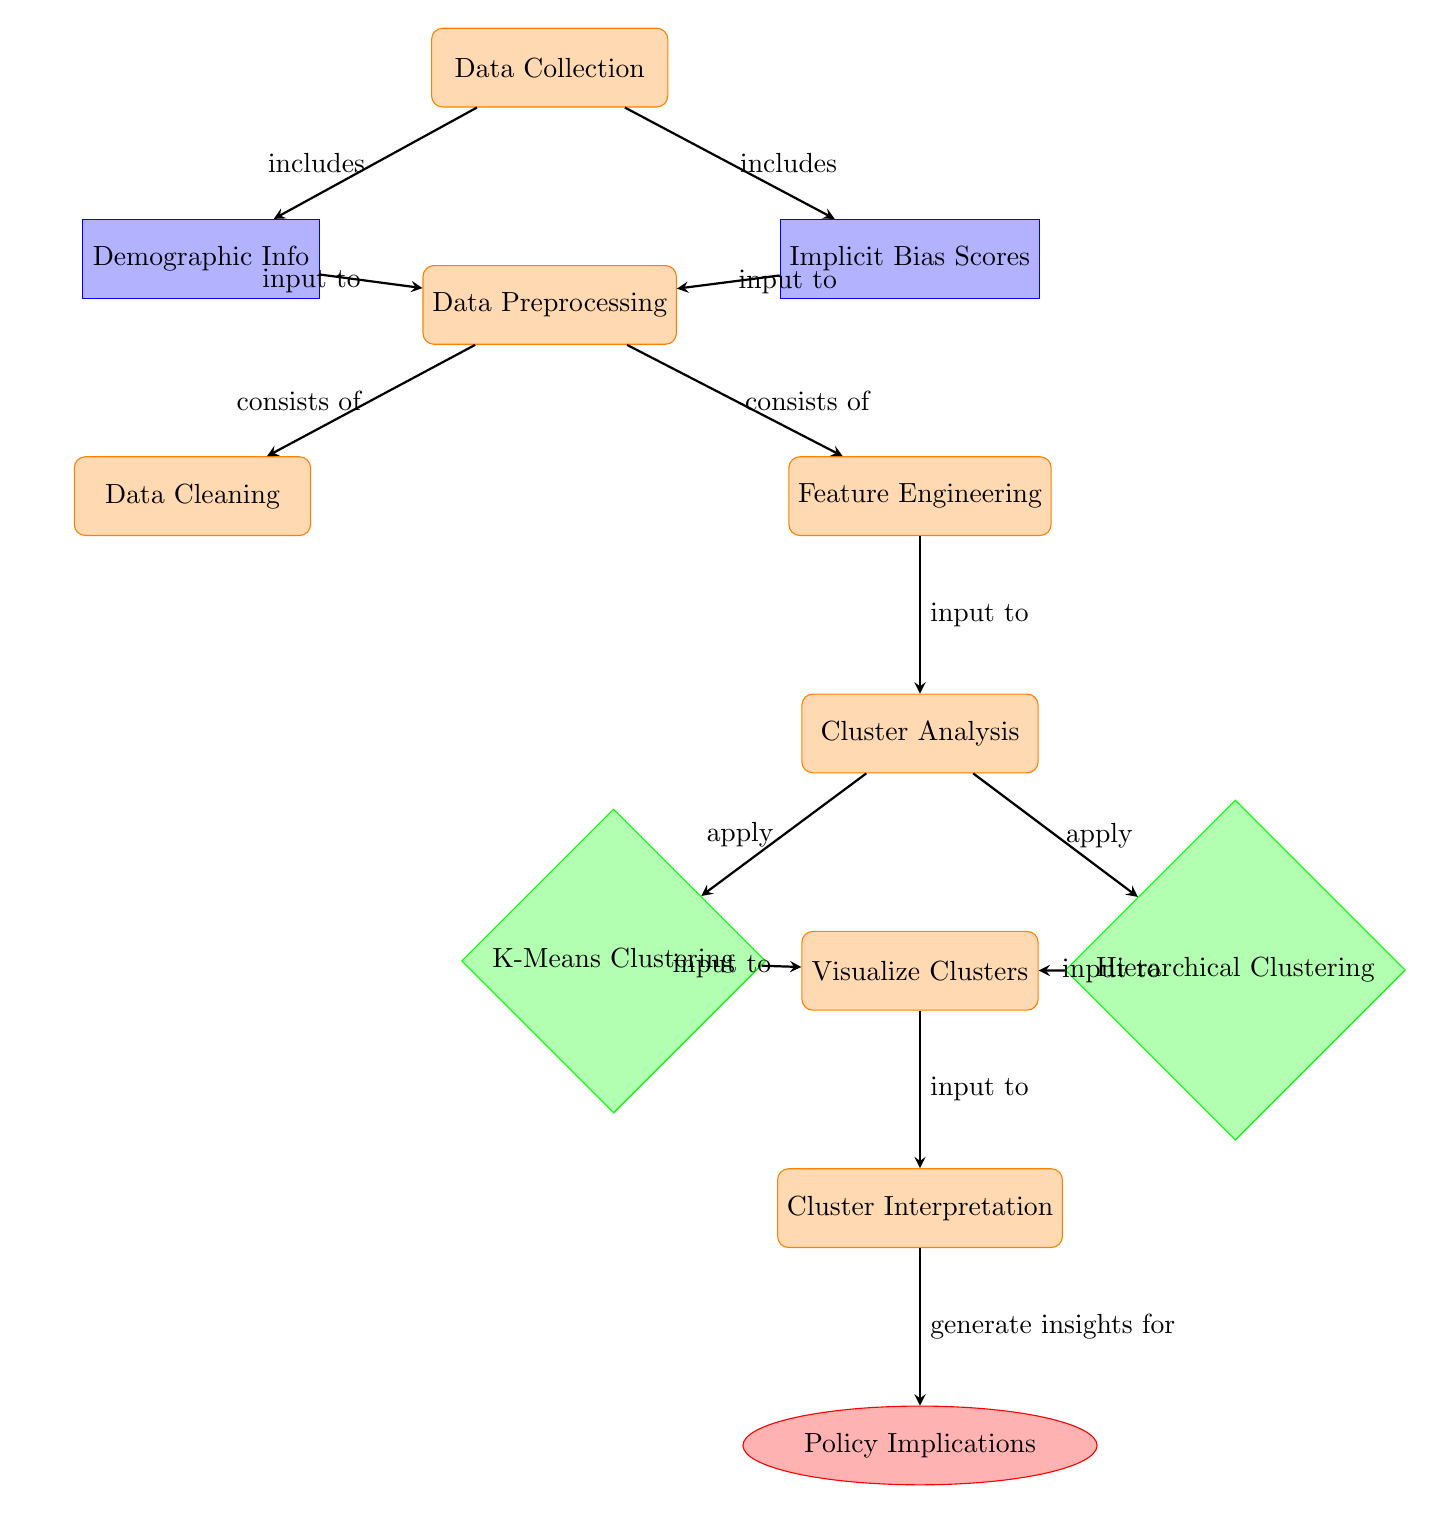What is the first step in the diagram? The first step in the diagram is "Data Collection," which is represented at the top of the flow. It indicates the initial action taken in the process before moving to the next steps.
Answer: Data Collection How many algorithms are used for clustering in the diagram? The diagram shows two algorithms used for clustering: "K-Means Clustering" and "Hierarchical Clustering." They are specifically indicated in the diagram under the cluster analysis.
Answer: 2 Which process comes directly after "Data Cleaning"? After "Data Cleaning," the next process in the diagram is "Feature Engineering." This follows the connections between nodes depicted in the process flow.
Answer: Feature Engineering What is the outcome of this diagram? The final output of the diagram is "Policy Implications," positioned at the bottom as the ultimate goal of the entire analysis workflow.
Answer: Policy Implications What connects "Implicit Bias Scores" to "Data Preprocessing"? The connection is established by an arrow labeled "input to," indicating that "Implicit Bias Scores" serve as input in the "Data Preprocessing" step.
Answer: input to Which two processes apply cluster analysis? The processes that apply cluster analysis are "K-Means Clustering" and "Hierarchical Clustering," as shown in the diagram under the "Cluster Analysis" section.
Answer: K-Means Clustering and Hierarchical Clustering What type of diagram is presented in this visual? The diagram presented is a "Machine Learning Diagram," illustrating the steps involved in analyzing implicit bias scores and it follows a structured flow of processes and outcomes.
Answer: Machine Learning Diagram What is the relationship between "Visualize Clusters" and "Cluster Interpretation"? The relationship is that "Visualize Clusters" inputs into "Cluster Interpretation," as shown by the arrow connecting these two processes, indicating a sequential workflow.
Answer: input to 